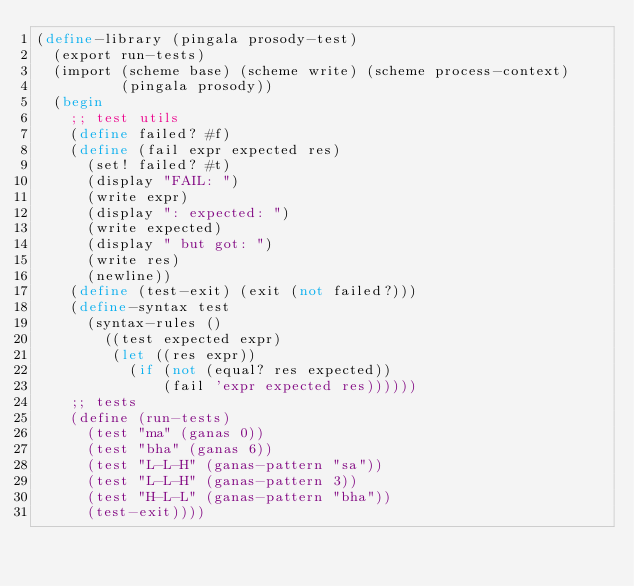<code> <loc_0><loc_0><loc_500><loc_500><_Scheme_>(define-library (pingala prosody-test)
  (export run-tests)
  (import (scheme base) (scheme write) (scheme process-context)
          (pingala prosody))
  (begin
    ;; test utils
    (define failed? #f)
    (define (fail expr expected res)
      (set! failed? #t)
      (display "FAIL: ")
      (write expr)
      (display ": expected: ")
      (write expected)
      (display " but got: ")
      (write res)
      (newline))
    (define (test-exit) (exit (not failed?)))
    (define-syntax test
      (syntax-rules ()
        ((test expected expr)
         (let ((res expr))
           (if (not (equal? res expected))
               (fail 'expr expected res))))))
    ;; tests
    (define (run-tests)
      (test "ma" (ganas 0))
      (test "bha" (ganas 6))
      (test "L-L-H" (ganas-pattern "sa"))
      (test "L-L-H" (ganas-pattern 3))
      (test "H-L-L" (ganas-pattern "bha"))
      (test-exit))))
</code> 